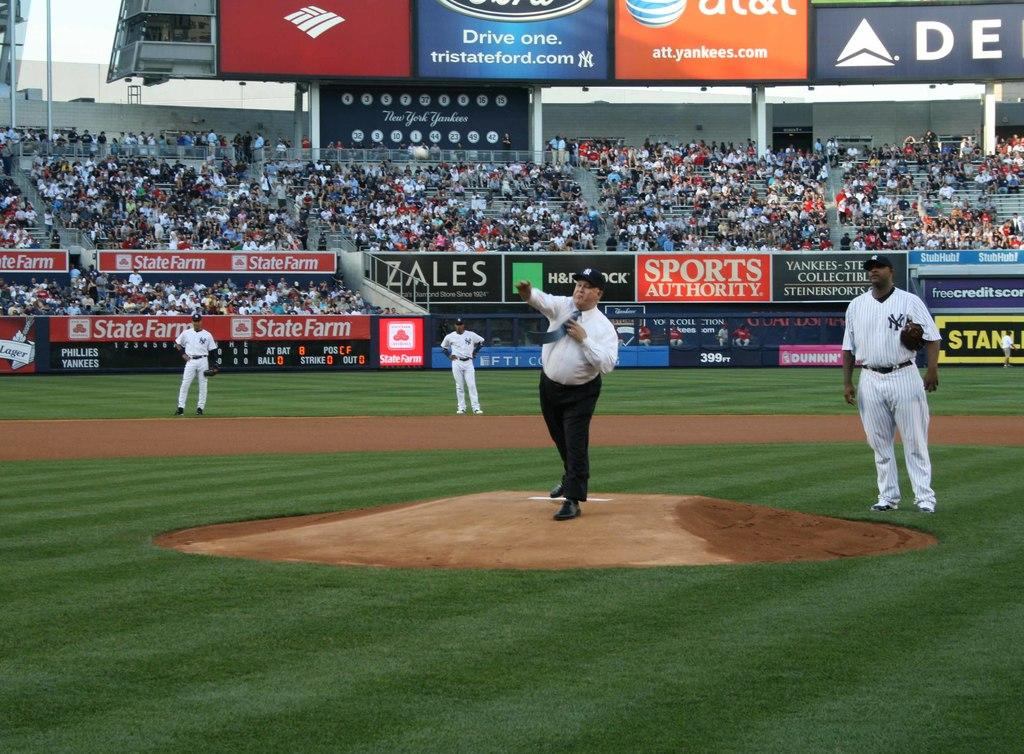<image>
Offer a succinct explanation of the picture presented. An overweight man wearing a tie throw the pitch on the field with ads like at&t. 